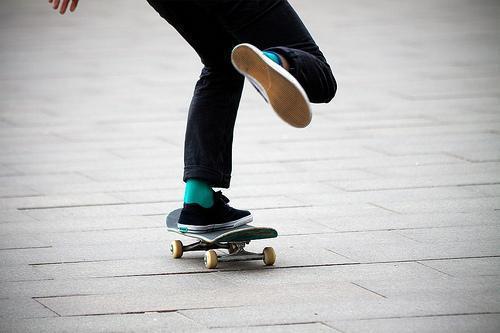How many skateboards are there?
Give a very brief answer. 1. 